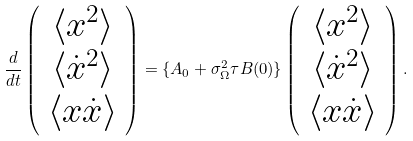Convert formula to latex. <formula><loc_0><loc_0><loc_500><loc_500>\frac { d } { d t } \left ( \begin{array} { c } \langle x ^ { 2 } \rangle \\ \langle \dot { x } ^ { 2 } \rangle \\ \langle x \dot { x } \rangle \end{array} \right ) = \{ { A } _ { 0 } + \sigma ^ { 2 } _ { \Omega } \tau { B } ( 0 ) \} \left ( \begin{array} { c } \langle x ^ { 2 } \rangle \\ \langle \dot { x } ^ { 2 } \rangle \\ \langle x \dot { x } \rangle \end{array} \right ) .</formula> 